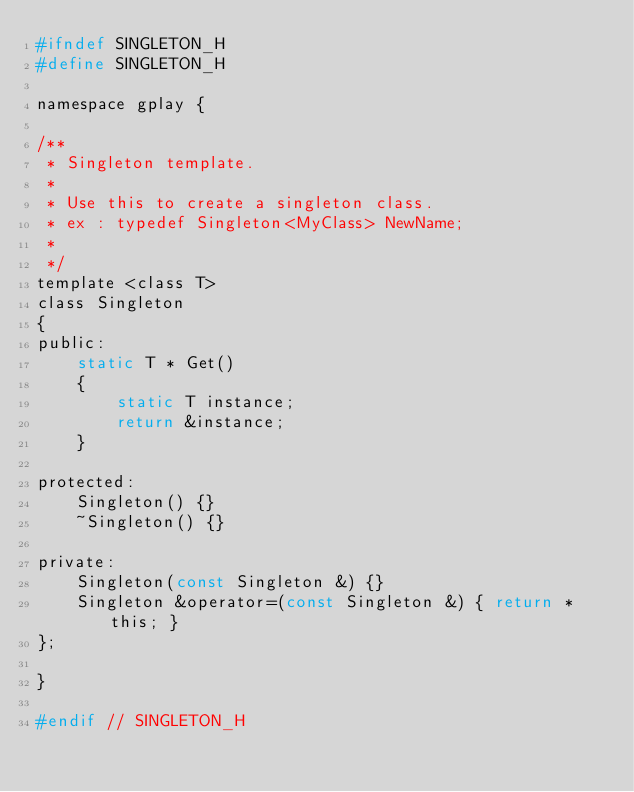<code> <loc_0><loc_0><loc_500><loc_500><_C_>#ifndef SINGLETON_H
#define SINGLETON_H

namespace gplay {

/**
 * Singleton template.
 *
 * Use this to create a singleton class.
 * ex : typedef Singleton<MyClass> NewName;
 *
 */
template <class T>
class Singleton
{
public:
    static T * Get()
    {
        static T instance;
        return &instance;
    }

protected:
    Singleton() {}
    ~Singleton() {}

private:
    Singleton(const Singleton &) {}
    Singleton &operator=(const Singleton &) { return *this; }
};

}

#endif // SINGLETON_H
</code> 